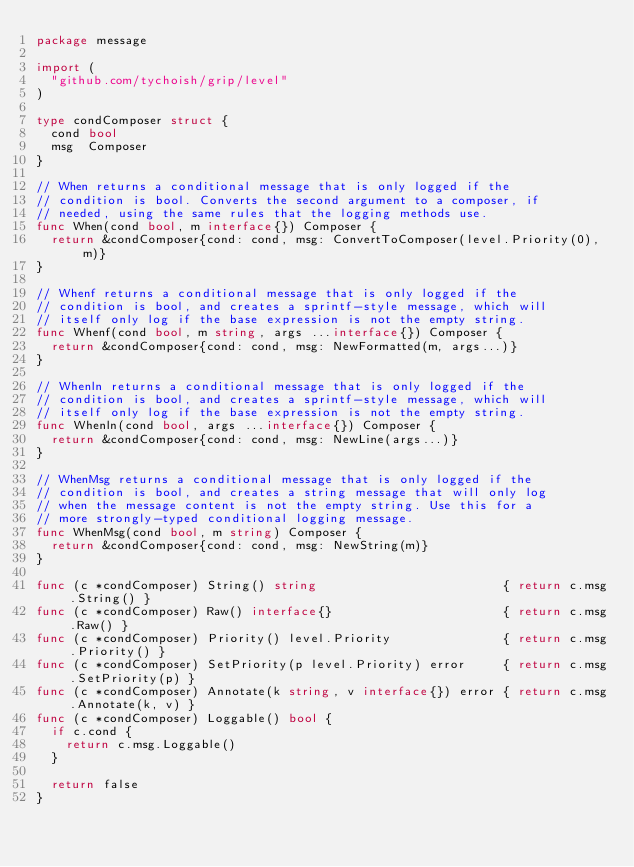Convert code to text. <code><loc_0><loc_0><loc_500><loc_500><_Go_>package message

import (
	"github.com/tychoish/grip/level"
)

type condComposer struct {
	cond bool
	msg  Composer
}

// When returns a conditional message that is only logged if the
// condition is bool. Converts the second argument to a composer, if
// needed, using the same rules that the logging methods use.
func When(cond bool, m interface{}) Composer {
	return &condComposer{cond: cond, msg: ConvertToComposer(level.Priority(0), m)}
}

// Whenf returns a conditional message that is only logged if the
// condition is bool, and creates a sprintf-style message, which will
// itself only log if the base expression is not the empty string.
func Whenf(cond bool, m string, args ...interface{}) Composer {
	return &condComposer{cond: cond, msg: NewFormatted(m, args...)}
}

// Whenln returns a conditional message that is only logged if the
// condition is bool, and creates a sprintf-style message, which will
// itself only log if the base expression is not the empty string.
func Whenln(cond bool, args ...interface{}) Composer {
	return &condComposer{cond: cond, msg: NewLine(args...)}
}

// WhenMsg returns a conditional message that is only logged if the
// condition is bool, and creates a string message that will only log
// when the message content is not the empty string. Use this for a
// more strongly-typed conditional logging message.
func WhenMsg(cond bool, m string) Composer {
	return &condComposer{cond: cond, msg: NewString(m)}
}

func (c *condComposer) String() string                         { return c.msg.String() }
func (c *condComposer) Raw() interface{}                       { return c.msg.Raw() }
func (c *condComposer) Priority() level.Priority               { return c.msg.Priority() }
func (c *condComposer) SetPriority(p level.Priority) error     { return c.msg.SetPriority(p) }
func (c *condComposer) Annotate(k string, v interface{}) error { return c.msg.Annotate(k, v) }
func (c *condComposer) Loggable() bool {
	if c.cond {
		return c.msg.Loggable()
	}

	return false
}
</code> 